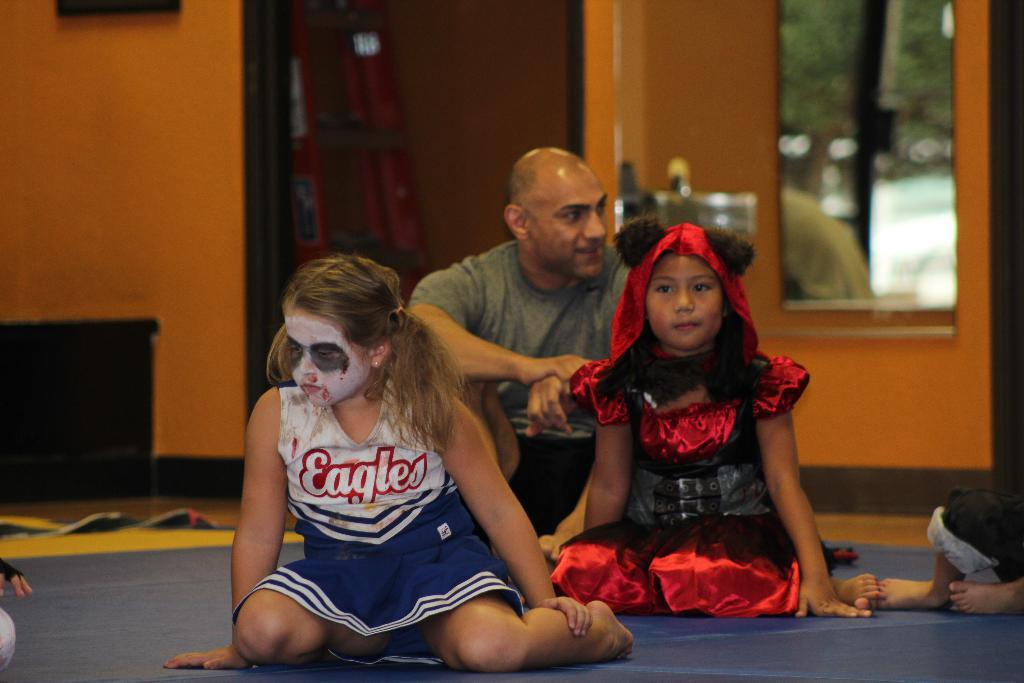Provide a one-sentence caption for the provided image. Girl with face paint and an Eagles jersey looking sad. 